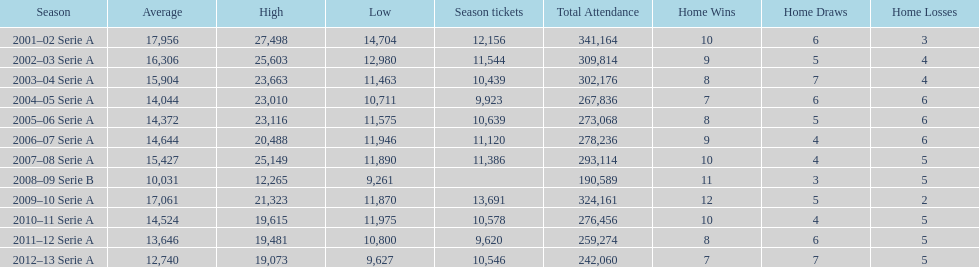How many seasons had average attendance of at least 15,000 at the stadio ennio tardini? 5. Could you parse the entire table? {'header': ['Season', 'Average', 'High', 'Low', 'Season tickets', 'Total Attendance', 'Home Wins', 'Home Draws', 'Home Losses'], 'rows': [['2001–02 Serie A', '17,956', '27,498', '14,704', '12,156', '341,164', '10', '6', '3'], ['2002–03 Serie A', '16,306', '25,603', '12,980', '11,544', '309,814', '9', '5', '4'], ['2003–04 Serie A', '15,904', '23,663', '11,463', '10,439', '302,176', '8', '7', '4'], ['2004–05 Serie A', '14,044', '23,010', '10,711', '9,923', '267,836', '7', '6', '6'], ['2005–06 Serie A', '14,372', '23,116', '11,575', '10,639', '273,068', '8', '5', '6'], ['2006–07 Serie A', '14,644', '20,488', '11,946', '11,120', '278,236', '9', '4', '6'], ['2007–08 Serie A', '15,427', '25,149', '11,890', '11,386', '293,114', '10', '4', '5'], ['2008–09 Serie B', '10,031', '12,265', '9,261', '', '190,589', '11', '3', '5'], ['2009–10 Serie A', '17,061', '21,323', '11,870', '13,691', '324,161', '12', '5', '2'], ['2010–11 Serie A', '14,524', '19,615', '11,975', '10,578', '276,456', '10', '4', '5'], ['2011–12 Serie A', '13,646', '19,481', '10,800', '9,620', '259,274', '8', '6', '5'], ['2012–13 Serie A', '12,740', '19,073', '9,627', '10,546', '242,060', '7', '7', '5']]} 